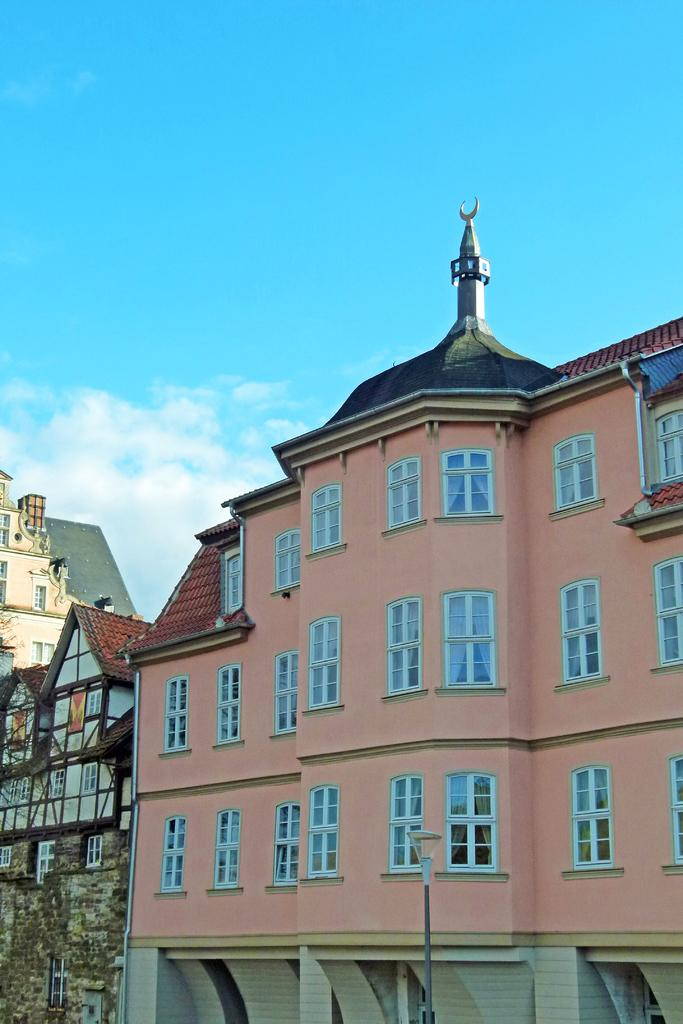What type of structures can be seen in the image? There are buildings in the image. What else is present in the image besides the buildings? There is a light pole in the image. What can be seen in the background of the image? The sky is visible in the background of the image. What is the condition of the sky in the image? Clouds are present in the sky. What type of soap is being used to clean the buildings in the image? There is no soap or cleaning activity present in the image; it simply shows buildings, a light pole, and the sky. 